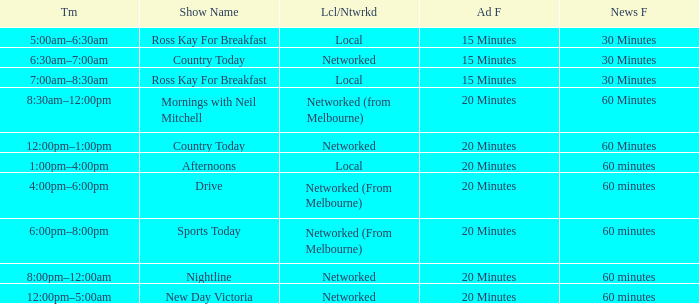What Time has a Show Name of mornings with neil mitchell? 8:30am–12:00pm. 